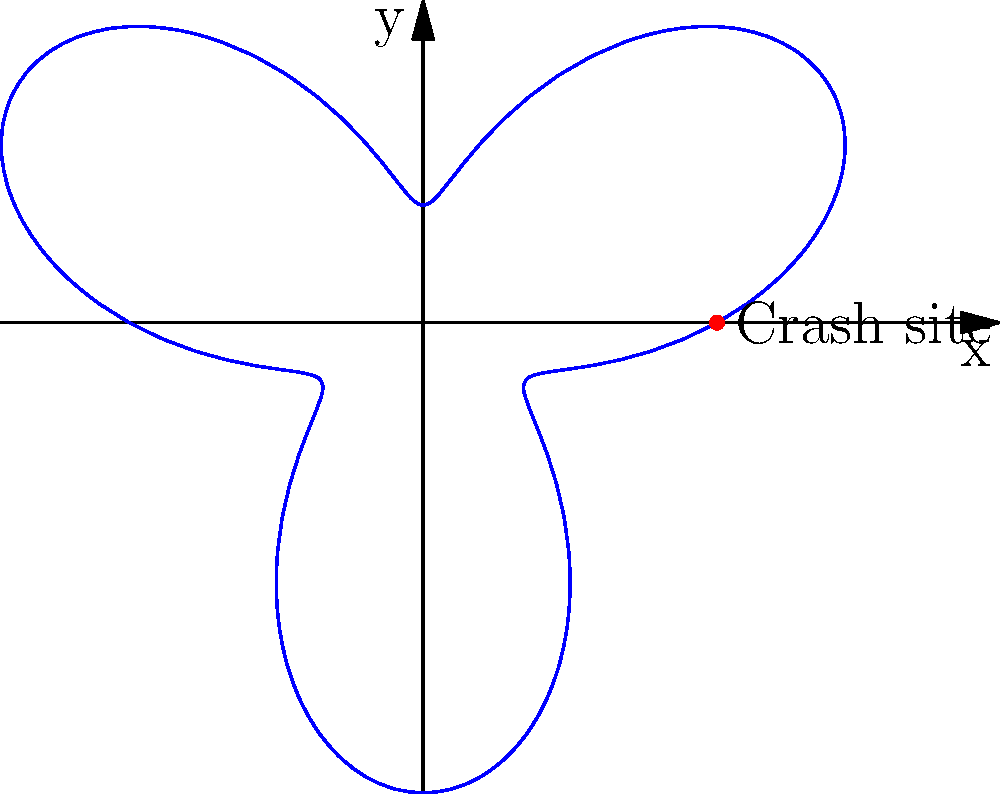In the polar coordinate system shown, the trajectory of Oceanic Flight 815 is represented by the equation $r = 5 + 3\sin(3\theta)$. If the crash site is located at the point (5,0), at how many other points does the flight path intersect with this radial distance from the origin? To solve this problem, we need to follow these steps:

1) The equation $r = 5 + 3\sin(3\theta)$ represents the flight path.

2) We're looking for points where $r = 5$, as the crash site is at (5,0).

3) This means we need to solve the equation:
   
   $5 = 5 + 3\sin(3\theta)$

4) Simplifying:
   
   $0 = 3\sin(3\theta)$

5) This is true when $\sin(3\theta) = 0$

6) $\sin(x) = 0$ when $x = 0, \pi, 2\pi, ...$

7) So, $3\theta = 0, \pi, 2\pi, 3\pi, 4\pi, 5\pi, 6\pi$

8) Solving for $\theta$:
   
   $\theta = 0, \frac{\pi}{3}, \frac{2\pi}{3}, \pi, \frac{4\pi}{3}, \frac{5\pi}{3}, 2\pi$

9) The point at $\theta = 0$ is the crash site we already know about.

10) Therefore, there are 6 other points where the flight path intersects with the radial distance of 5 from the origin.
Answer: 6 